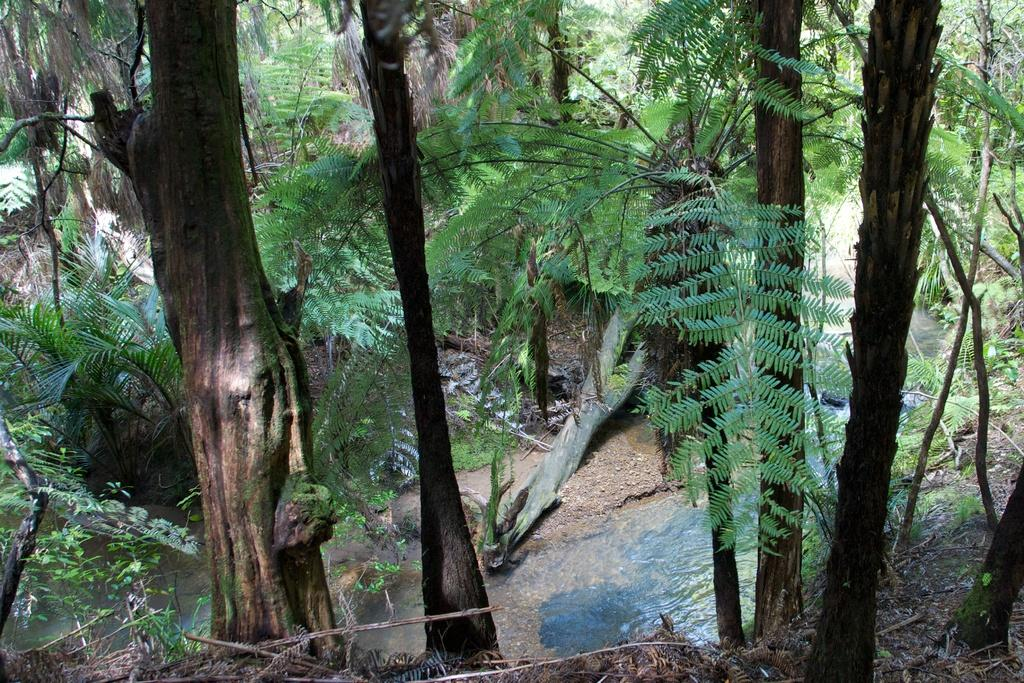What type of natural environment is depicted in the image? The image contains a view of a forest. What is the closest object to the viewer in the image? There is a tree trunk in the front of the image. What color are the trees in the background of the image? There are green. How many boys are paying attention to the tree trunk in the image? There are no boys present in the image, so it is not possible to determine how many are paying attention to the tree trunk. 